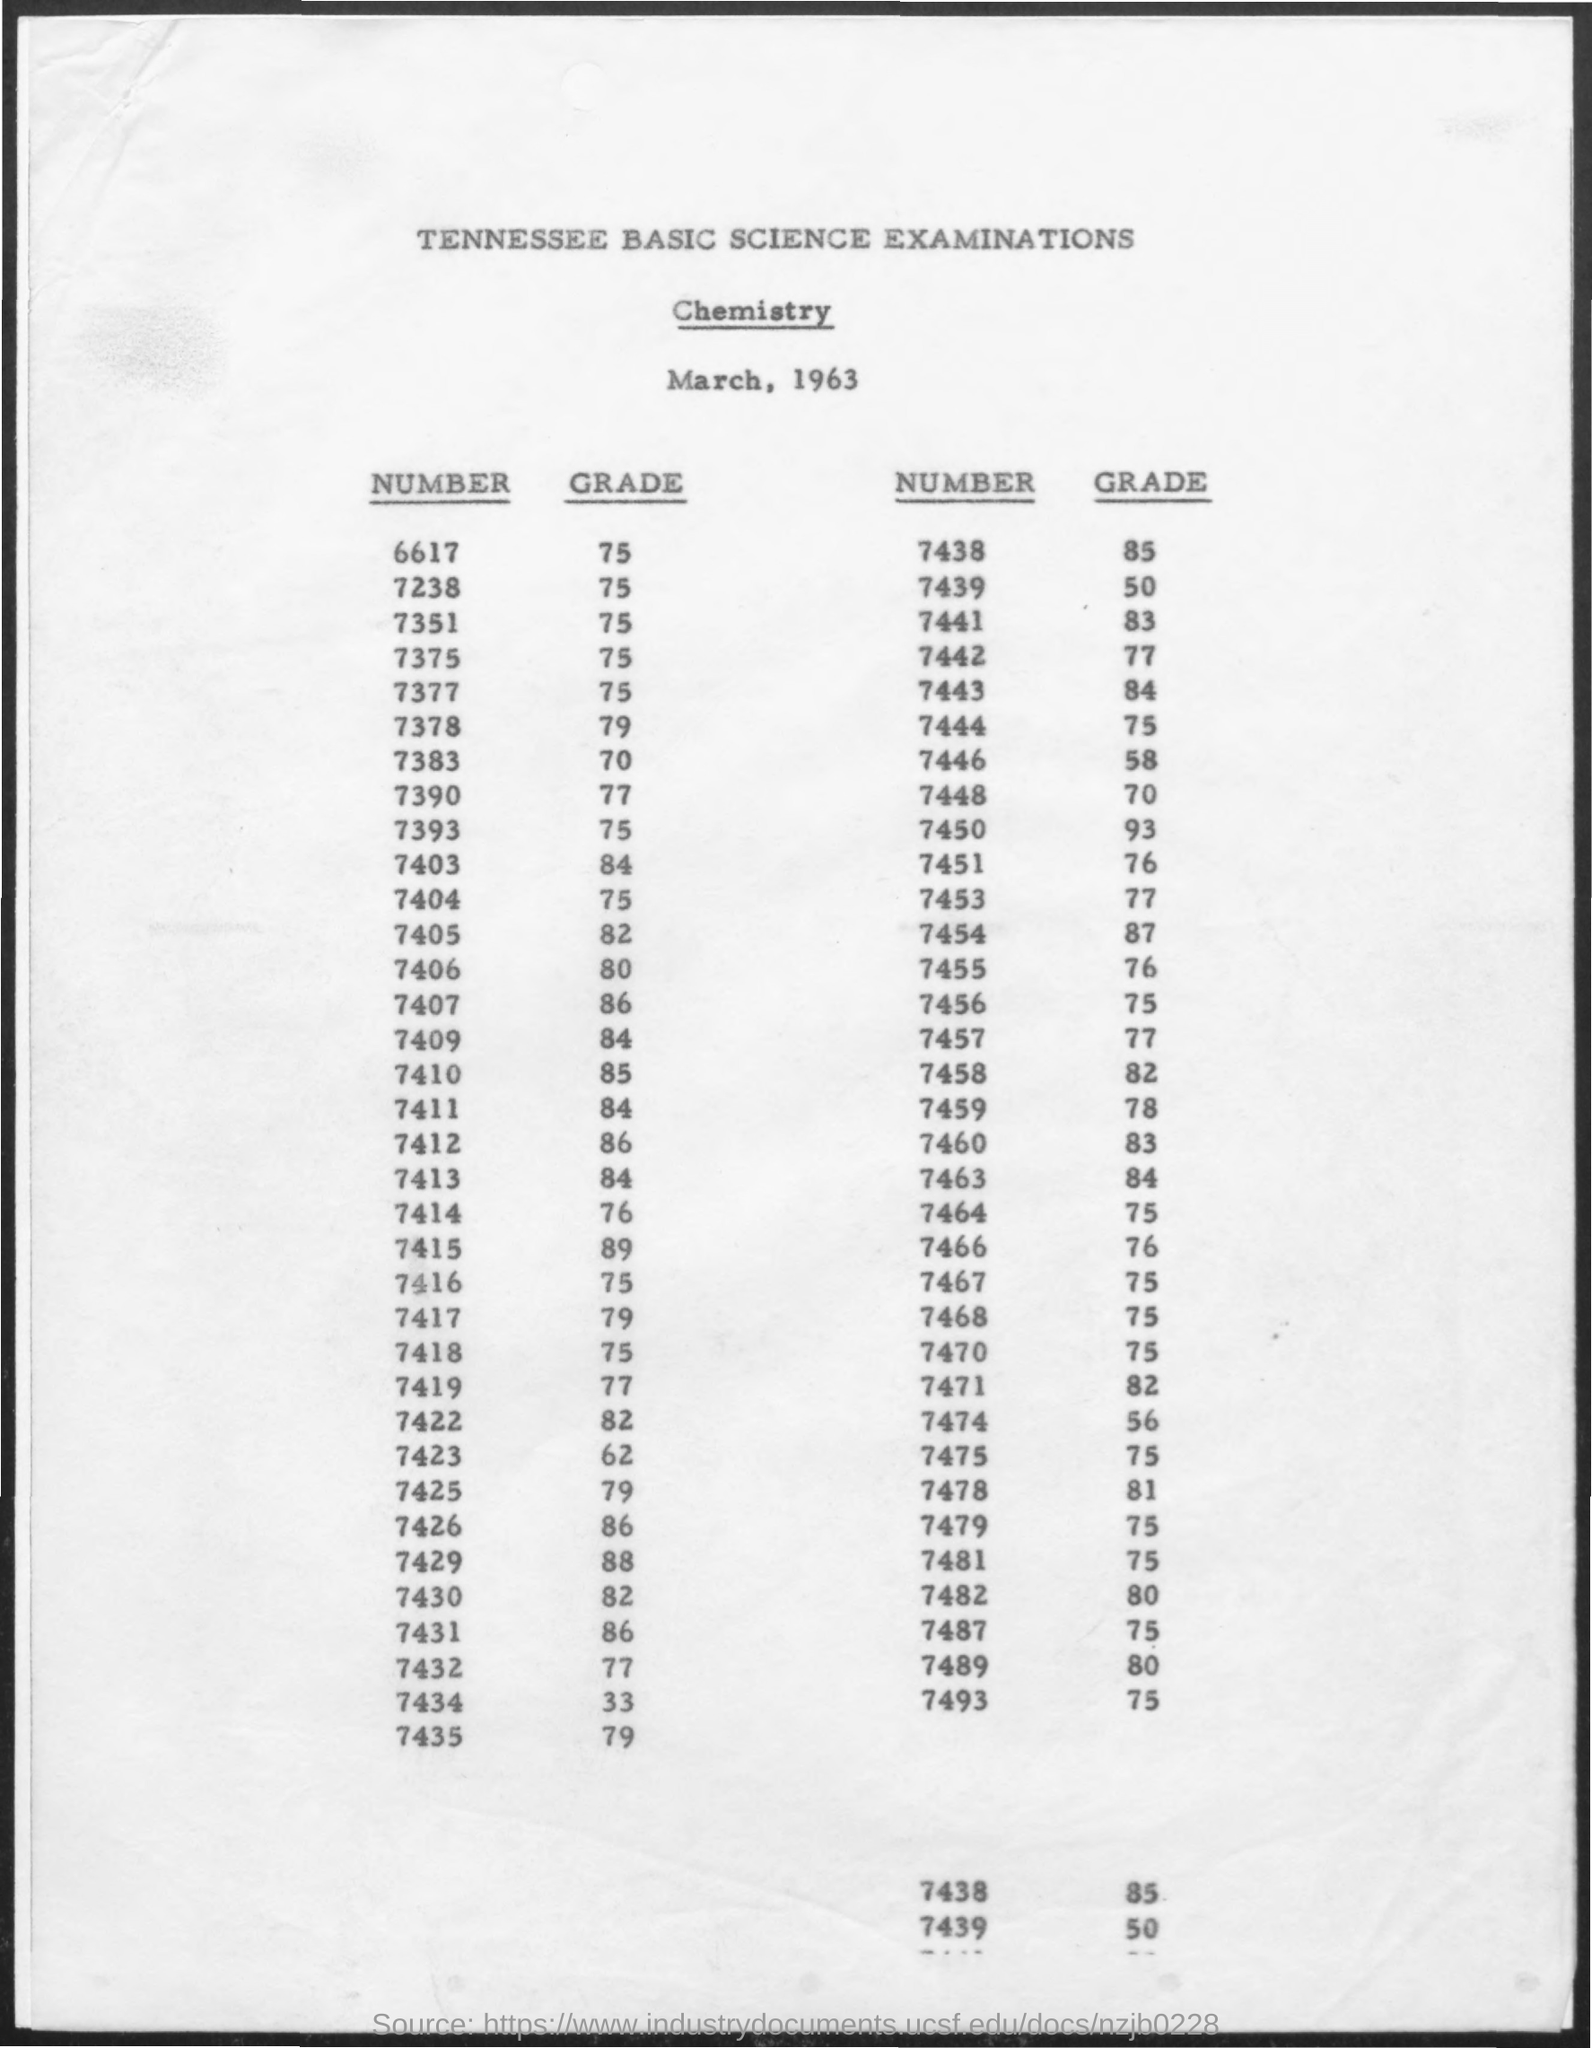what is the grade for the number 7438 ?
 85 